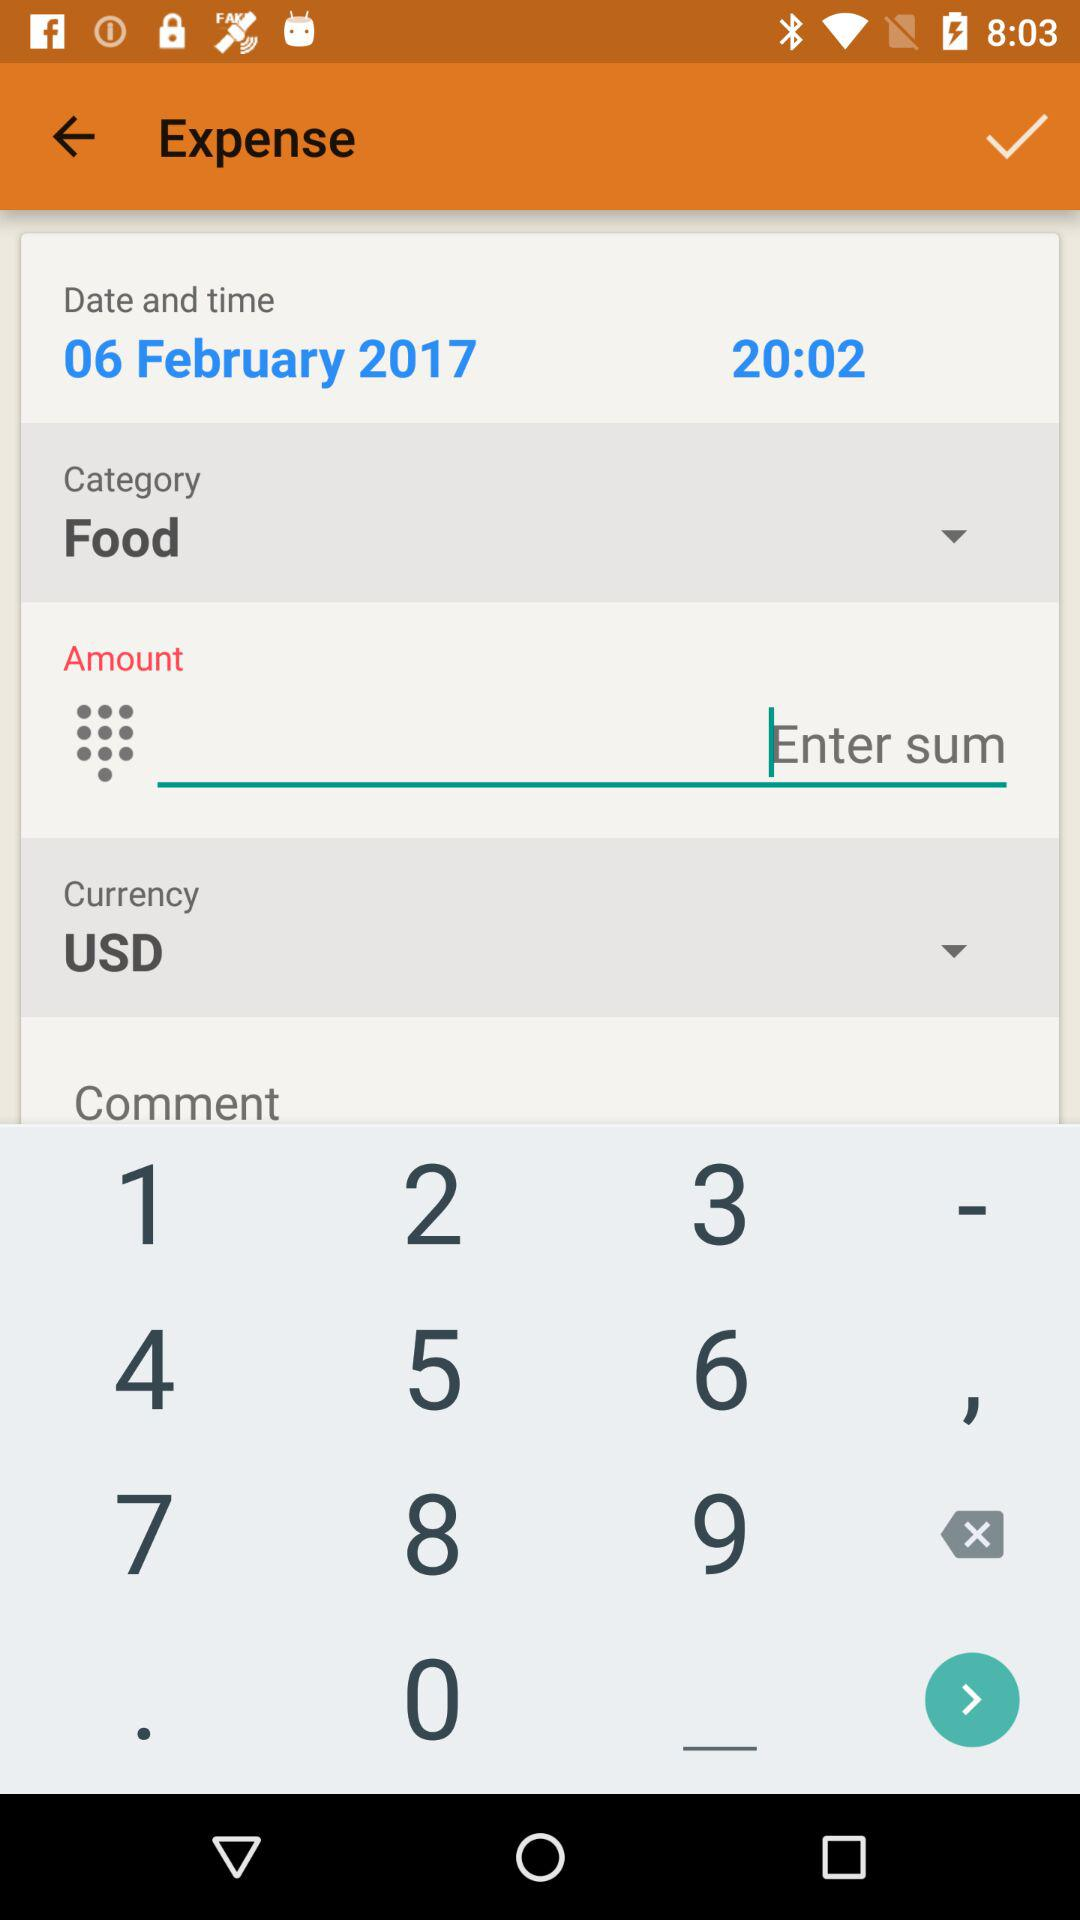What date and time are mentioned? The mentioned date and time are February 6, 2017 and 20:02 respectively. 